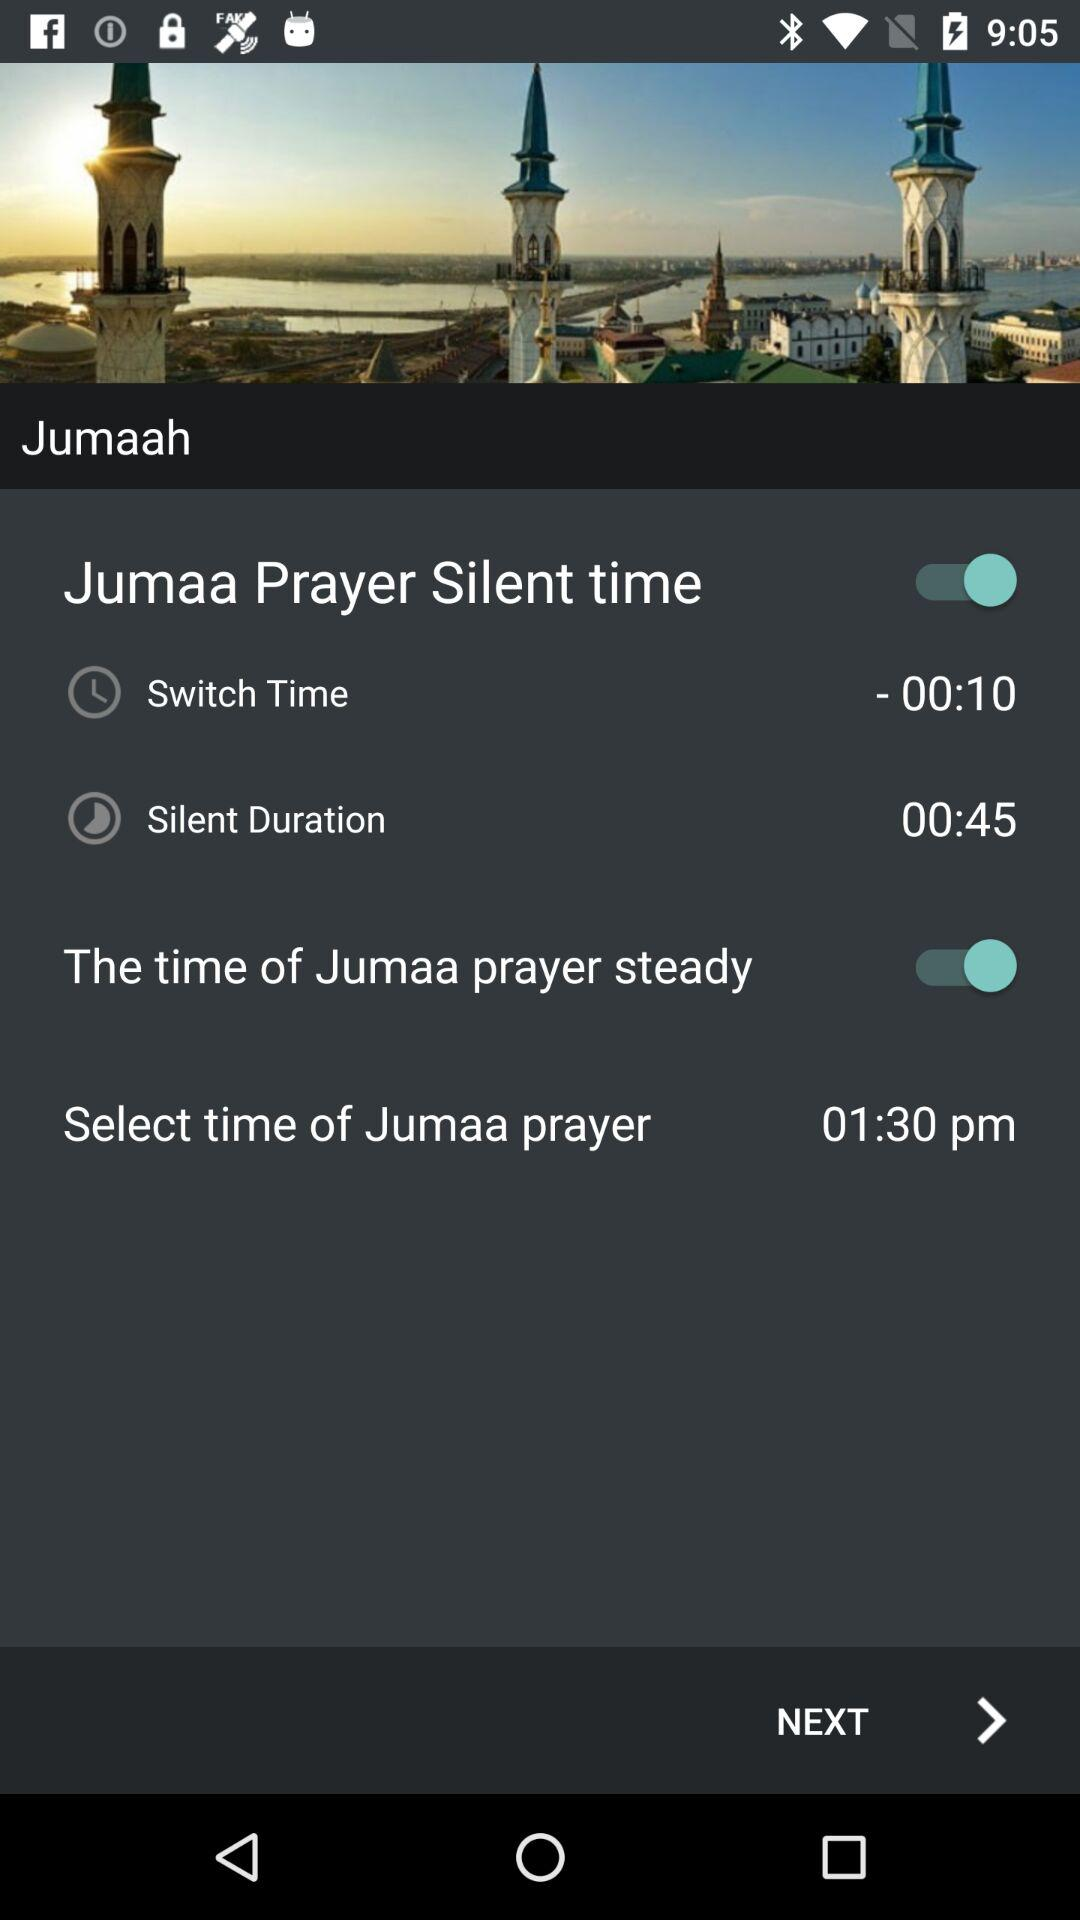What is the status of "Jumma Prayer Silent time"? The status is "on". 